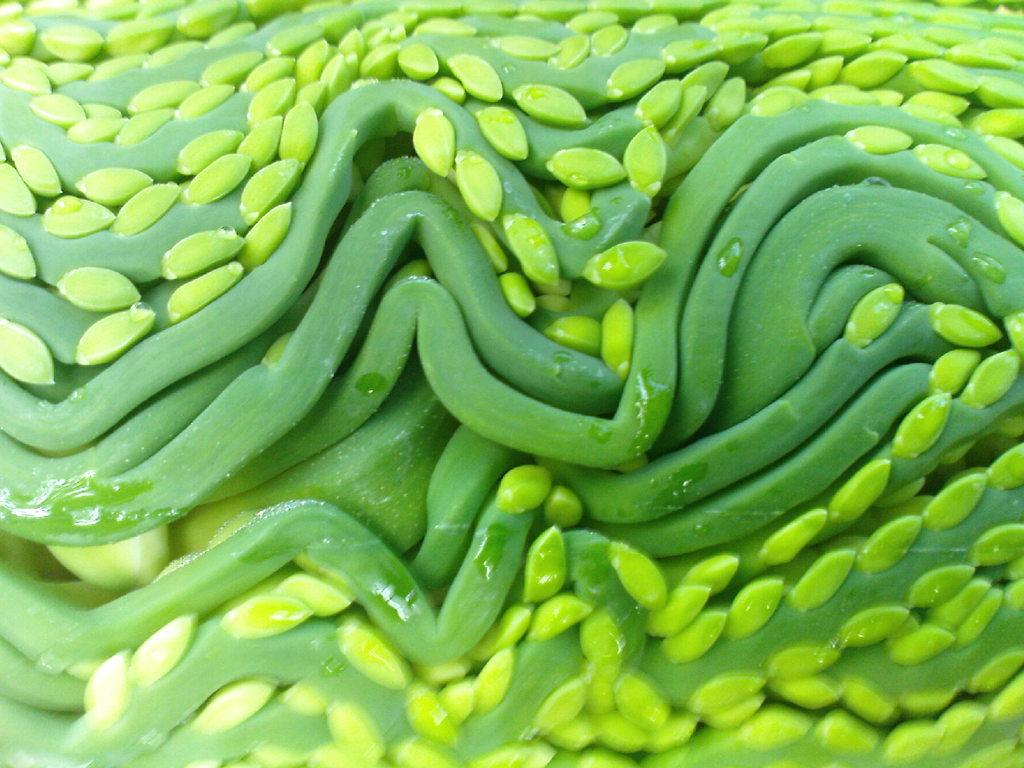What type of food can be seen in the image? There are green vegetables in the image. Can you describe the color of the vegetables? The vegetables are green. What might be a possible use for the green vegetables in the image? The green vegetables could be used for cooking or as a healthy snack. What type of machine is responsible for producing the wax in the image? There is no machine or wax present in the image; it only features green vegetables. 